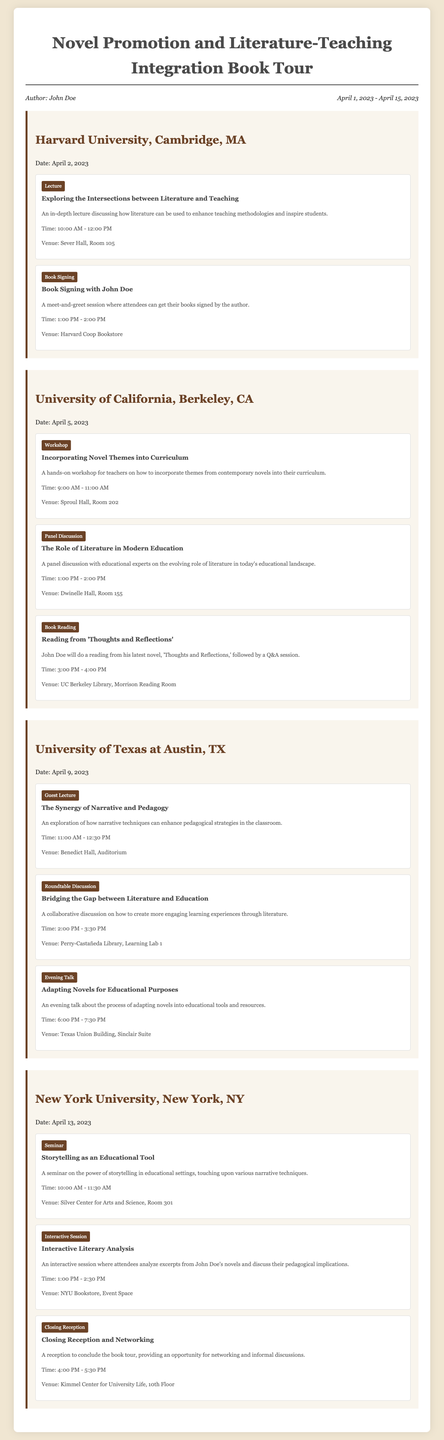What is the author's name? The author's name is mentioned in the tour information at the top of the document.
Answer: John Doe What is the first university stop on the tour? The first university stop is outlined in the first section of the document.
Answer: Harvard University, Cambridge, MA What type of event is scheduled for April 5, 2023, at UC Berkeley? The type of event is identified in the events listed for that date in the itinerary.
Answer: Workshop What time does the lecture at Harvard University start? The start time for the lecture is provided in the details of the event section for Harvard University.
Answer: 10:00 AM Which venue hosts the evening talk at the University of Texas at Austin? The venue is mentioned in the event details section for the evening talk.
Answer: Texas Union Building, Sinclair Suite How many events are planned for April 9, 2023, at the University of Texas at Austin? The total number of events can be counted within the listing for that university.
Answer: Three What is the focus of the seminar at New York University? The topic focus is stated in the title and description of the seminar.
Answer: Storytelling as an Educational Tool What is the venue for the closing reception on April 13, 2023? The venue is specified in the details of the closing reception event.
Answer: Kimmel Center for University Life, 10th Floor 